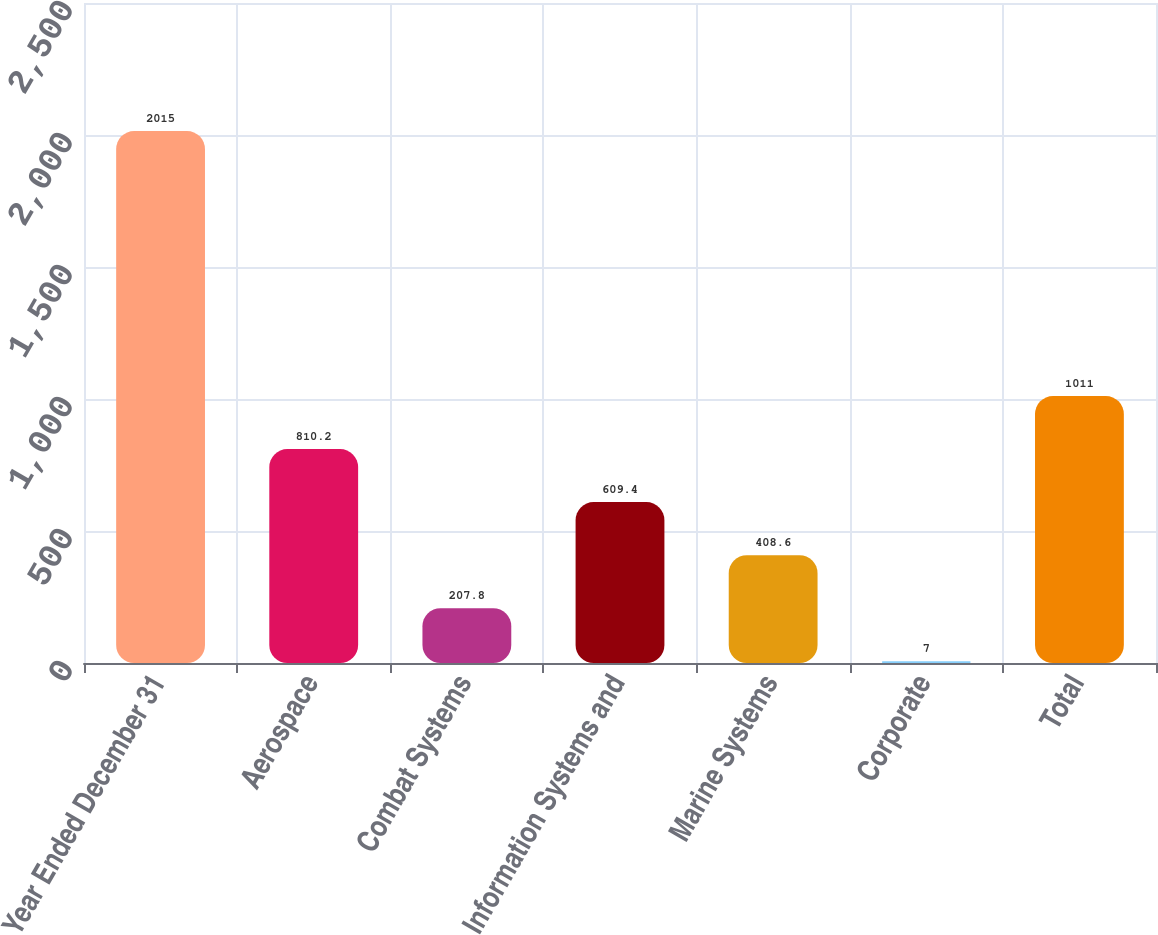Convert chart. <chart><loc_0><loc_0><loc_500><loc_500><bar_chart><fcel>Year Ended December 31<fcel>Aerospace<fcel>Combat Systems<fcel>Information Systems and<fcel>Marine Systems<fcel>Corporate<fcel>Total<nl><fcel>2015<fcel>810.2<fcel>207.8<fcel>609.4<fcel>408.6<fcel>7<fcel>1011<nl></chart> 